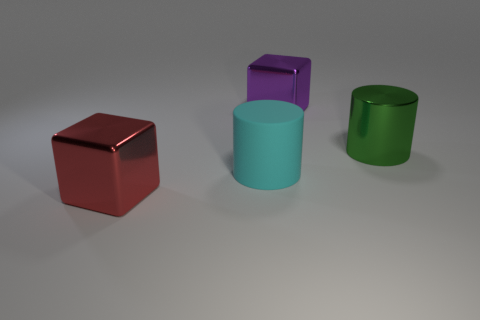What is the color of the matte thing that is the same size as the green shiny object?
Your answer should be very brief. Cyan. What number of tiny objects are either cyan metallic objects or metallic things?
Offer a very short reply. 0. Is the number of green metal cylinders on the left side of the cyan cylinder the same as the number of things that are in front of the large green metallic cylinder?
Keep it short and to the point. No. What number of blue blocks are the same size as the metallic cylinder?
Your answer should be compact. 0. What number of red things are metallic cubes or large matte cylinders?
Offer a terse response. 1. Are there the same number of cubes that are left of the large cyan object and large cyan matte cylinders?
Offer a terse response. Yes. What number of other large green metal objects have the same shape as the large green shiny object?
Provide a short and direct response. 0. There is a object that is on the right side of the large red shiny cube and to the left of the purple shiny thing; what material is it made of?
Keep it short and to the point. Rubber. Is the big red thing made of the same material as the green cylinder?
Offer a very short reply. Yes. What number of big purple metal objects are there?
Your response must be concise. 1. 